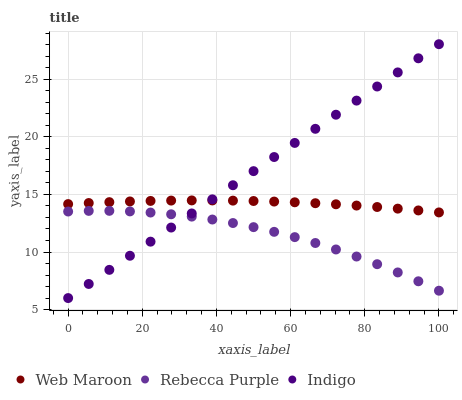Does Rebecca Purple have the minimum area under the curve?
Answer yes or no. Yes. Does Indigo have the maximum area under the curve?
Answer yes or no. Yes. Does Web Maroon have the minimum area under the curve?
Answer yes or no. No. Does Web Maroon have the maximum area under the curve?
Answer yes or no. No. Is Indigo the smoothest?
Answer yes or no. Yes. Is Rebecca Purple the roughest?
Answer yes or no. Yes. Is Web Maroon the smoothest?
Answer yes or no. No. Is Web Maroon the roughest?
Answer yes or no. No. Does Indigo have the lowest value?
Answer yes or no. Yes. Does Rebecca Purple have the lowest value?
Answer yes or no. No. Does Indigo have the highest value?
Answer yes or no. Yes. Does Web Maroon have the highest value?
Answer yes or no. No. Is Rebecca Purple less than Web Maroon?
Answer yes or no. Yes. Is Web Maroon greater than Rebecca Purple?
Answer yes or no. Yes. Does Indigo intersect Rebecca Purple?
Answer yes or no. Yes. Is Indigo less than Rebecca Purple?
Answer yes or no. No. Is Indigo greater than Rebecca Purple?
Answer yes or no. No. Does Rebecca Purple intersect Web Maroon?
Answer yes or no. No. 